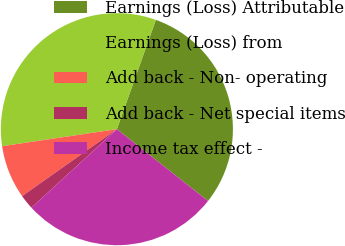Convert chart to OTSL. <chart><loc_0><loc_0><loc_500><loc_500><pie_chart><fcel>Earnings (Loss) Attributable<fcel>Earnings (Loss) from<fcel>Add back - Non- operating<fcel>Add back - Net special items<fcel>Income tax effect -<nl><fcel>30.17%<fcel>32.8%<fcel>7.44%<fcel>2.04%<fcel>27.55%<nl></chart> 